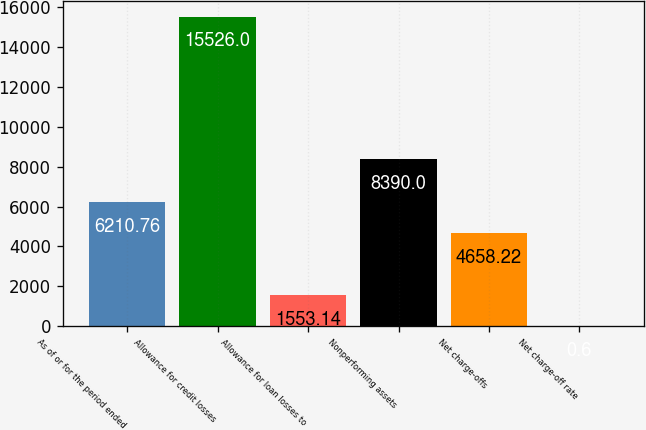Convert chart to OTSL. <chart><loc_0><loc_0><loc_500><loc_500><bar_chart><fcel>As of or for the period ended<fcel>Allowance for credit losses<fcel>Allowance for loan losses to<fcel>Nonperforming assets<fcel>Net charge-offs<fcel>Net charge-off rate<nl><fcel>6210.76<fcel>15526<fcel>1553.14<fcel>8390<fcel>4658.22<fcel>0.6<nl></chart> 